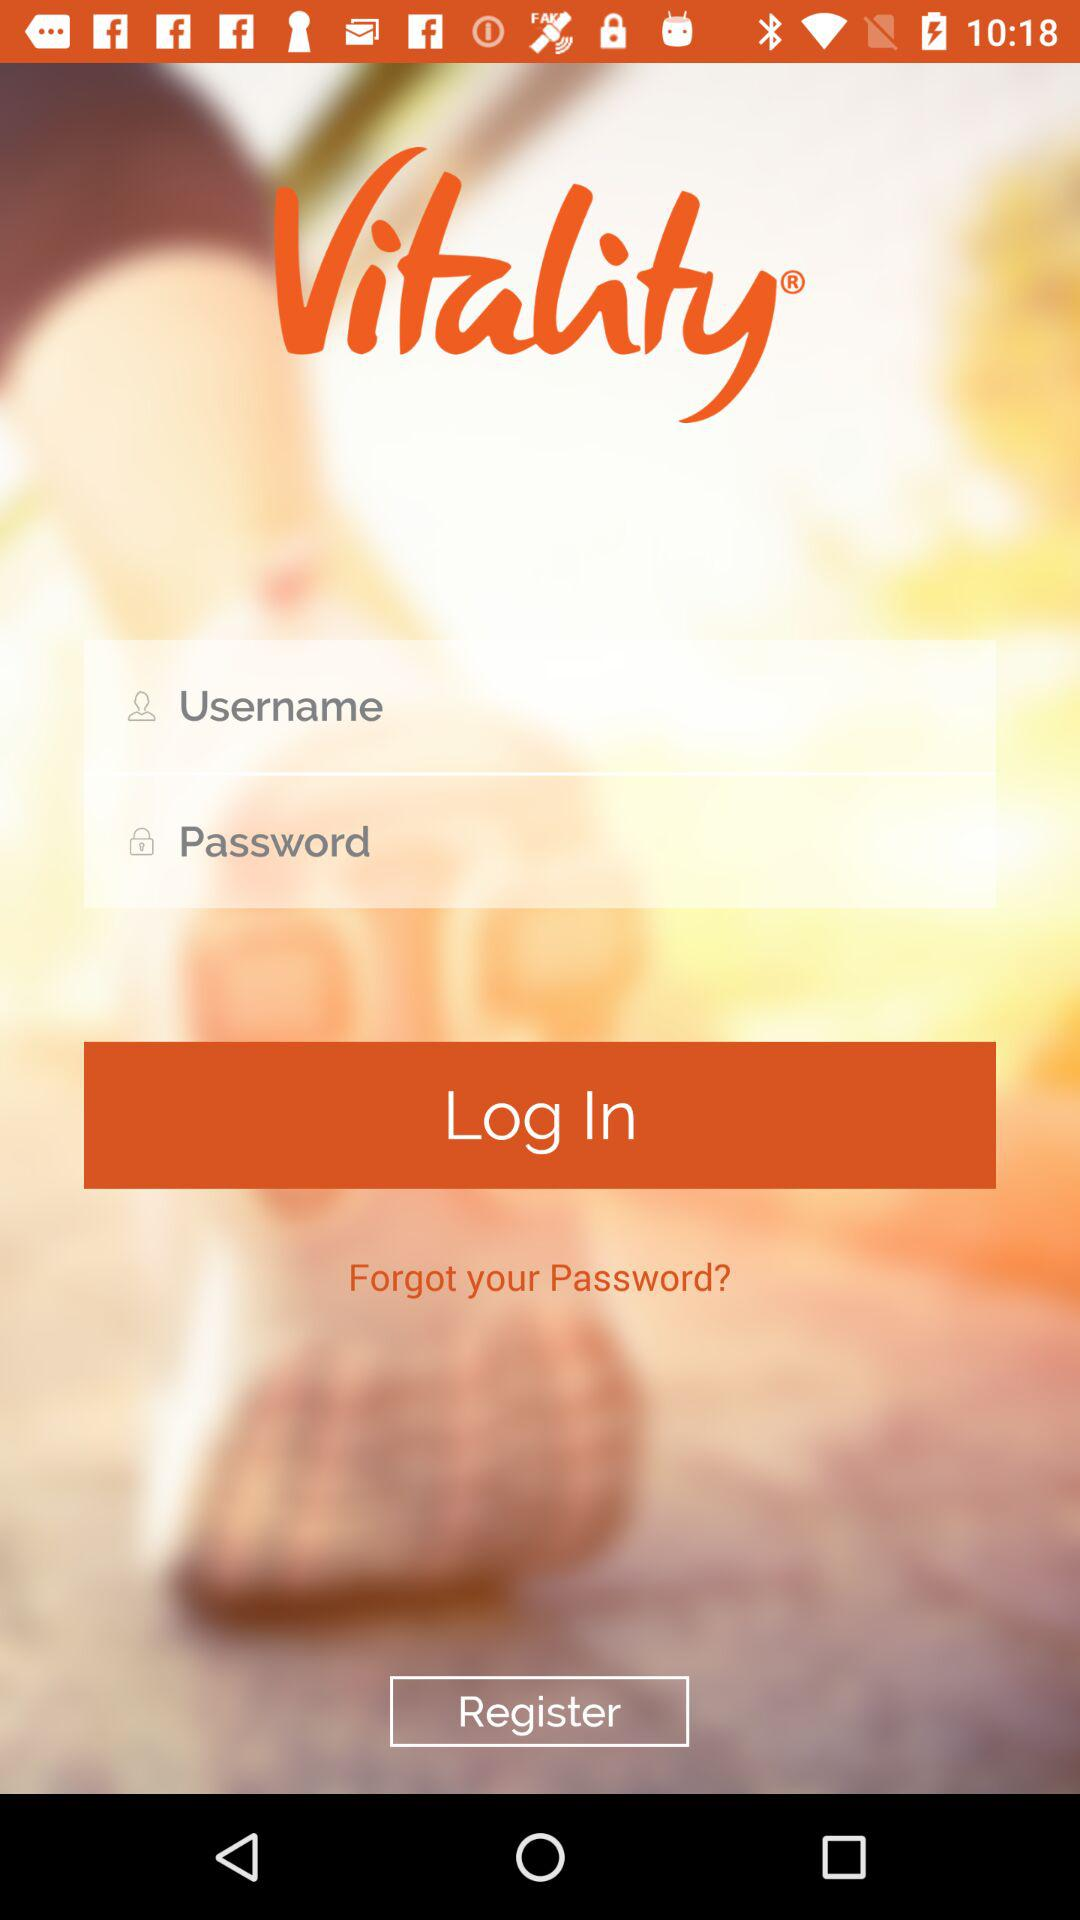What is the name of the application? The name of the application is "Vitality". 